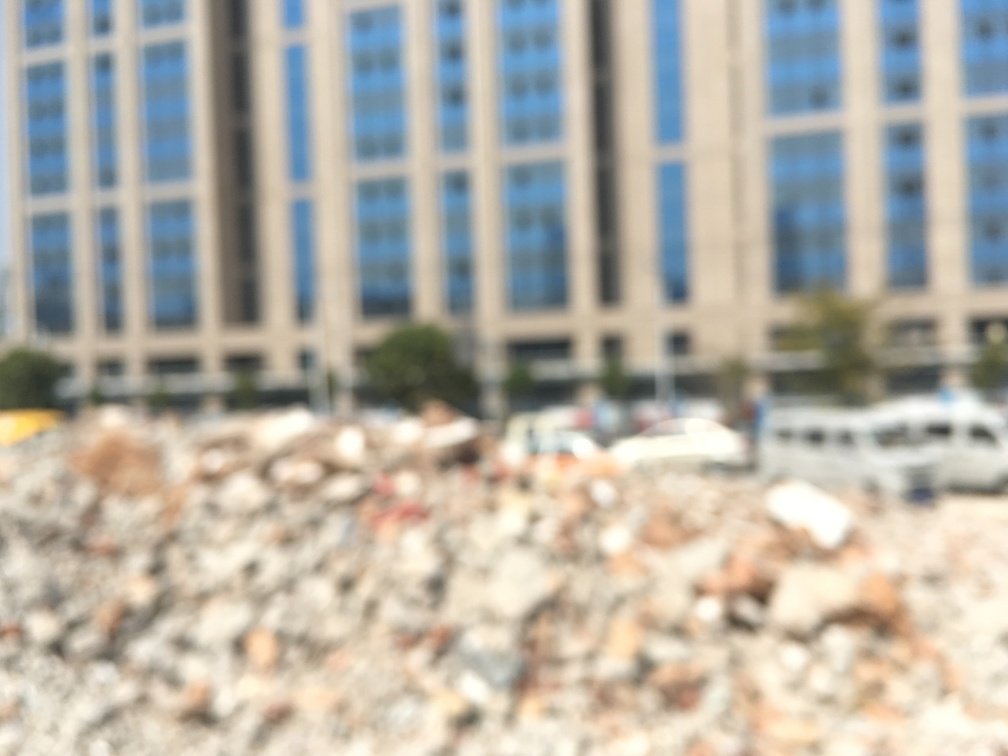Could the blurriness we see be indicative of a particular event or issue, such as pollution or a weather phenomenon? Blurriness in a photograph can arise from several factors, including camera movement, focus issues, or atmospheric conditions like fog or smog. With an image lacking clear context clues, it is difficult to pinpoint a definitive cause. If we were to imagine scenarios, the blurriness could imply a foggy day in an urban setting, possibly hinting at weather-related visibility difficulties. Alternatively, it might be suggestive of heavy pollution affecting air quality and clarity of view. The blurriness could also result from a moment captured in motion, perhaps symbolizing the hustle of city life. 